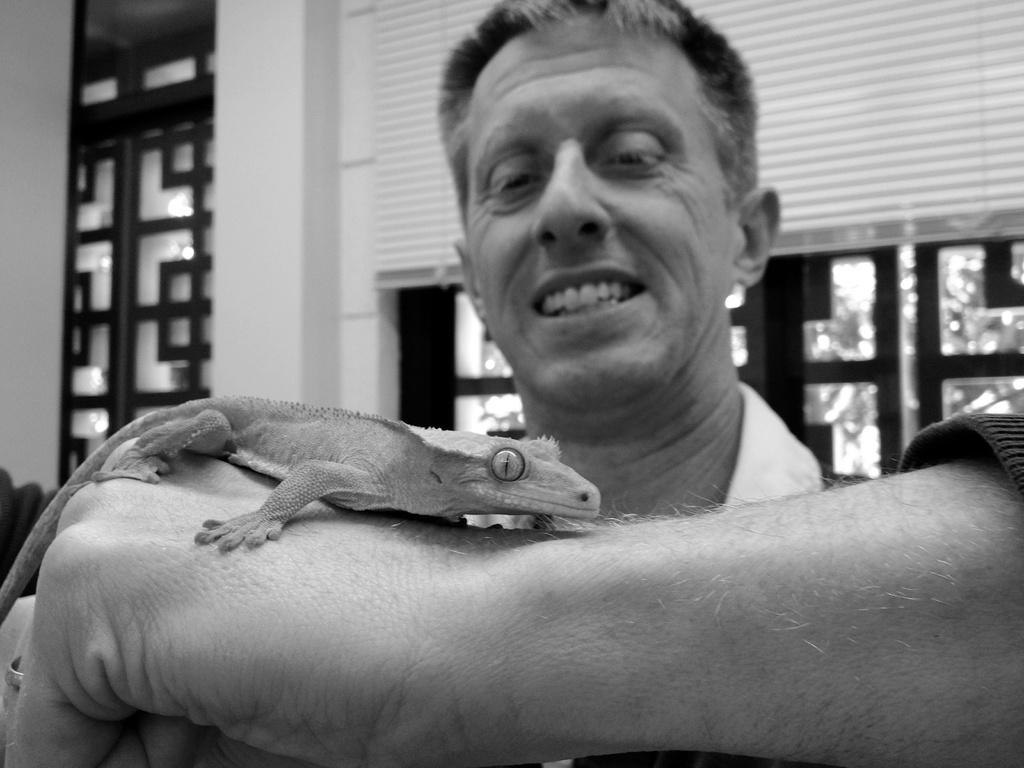Who is present in the image? There is a man in the image. What is the man wearing? The man is wearing clothes. What part of a person can be seen in the image? There is a human hand in the image. What type of animal is in the image? There is a lizard in the image. What architectural feature is visible in the image? There is a window and a wall in the image. What type of collar can be seen on the worm in the image? There is no worm present in the image, and therefore no collar can be seen on it. 